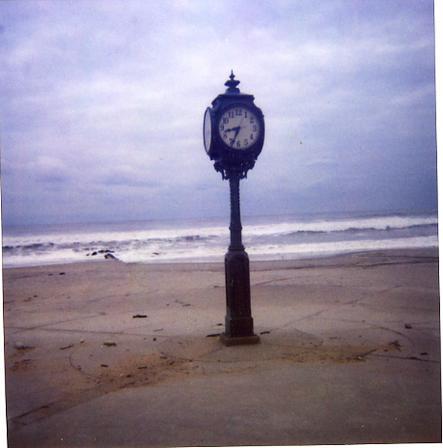Is it sunny?
Short answer required. No. How many faces would this clock have?
Give a very brief answer. 4. How many waves are breaking on the beach?
Write a very short answer. 2. Is this a beach?
Be succinct. Yes. 